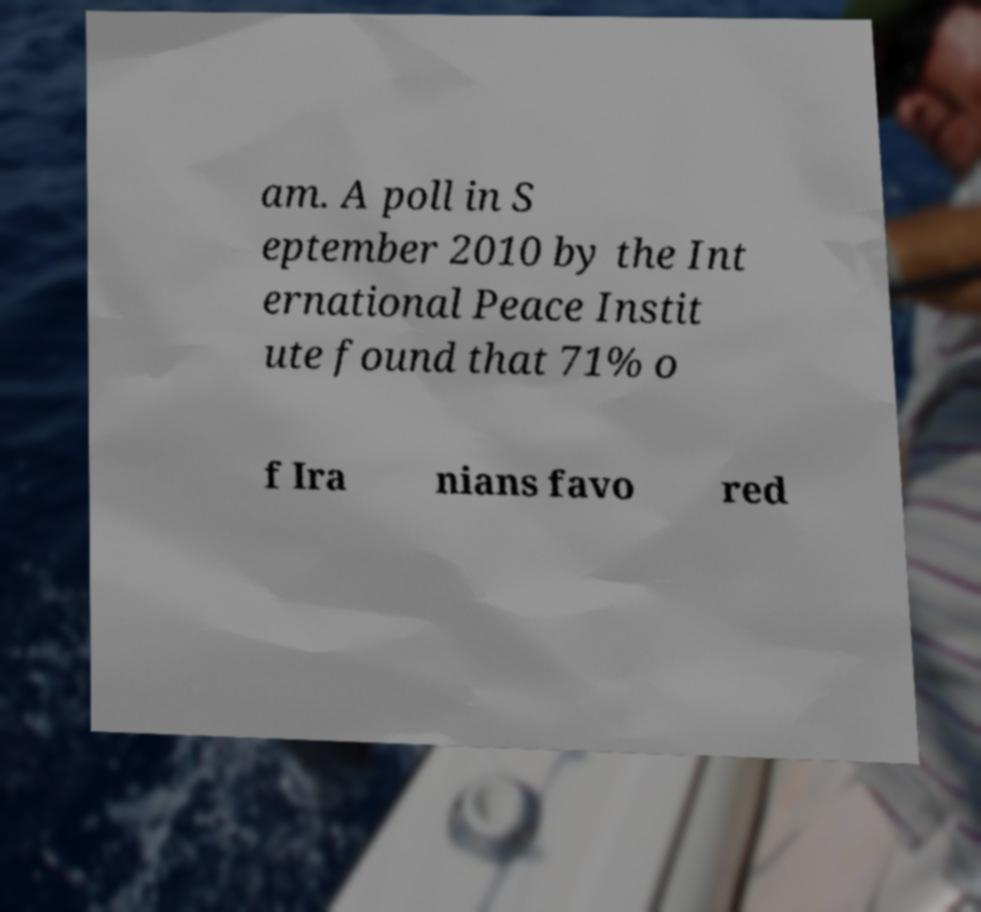For documentation purposes, I need the text within this image transcribed. Could you provide that? am. A poll in S eptember 2010 by the Int ernational Peace Instit ute found that 71% o f Ira nians favo red 